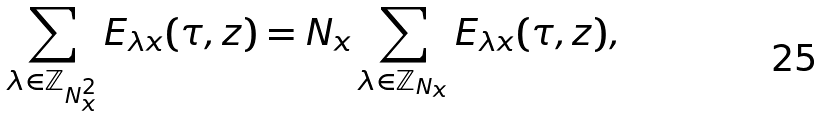<formula> <loc_0><loc_0><loc_500><loc_500>\sum _ { \lambda \in \mathbb { Z } _ { N _ { x } ^ { 2 } } } E _ { \lambda x } ( \tau , z ) = N _ { x } \sum _ { \lambda \in \mathbb { Z } _ { N _ { x } } } E _ { \lambda x } ( \tau , z ) ,</formula> 